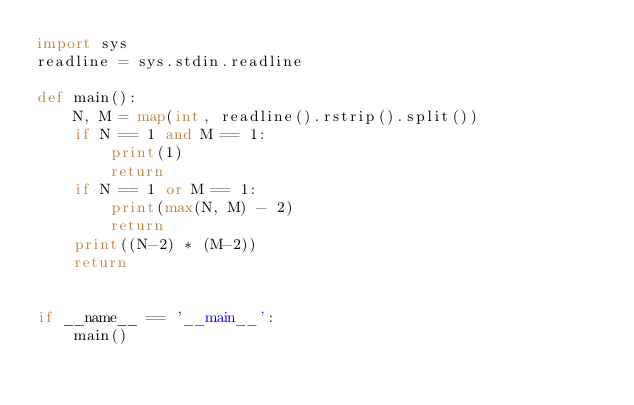<code> <loc_0><loc_0><loc_500><loc_500><_Python_>import sys
readline = sys.stdin.readline

def main():
    N, M = map(int, readline().rstrip().split())
    if N == 1 and M == 1:
        print(1)
        return
    if N == 1 or M == 1:
        print(max(N, M) - 2)
        return
    print((N-2) * (M-2))
    return


if __name__ == '__main__':
    main()</code> 